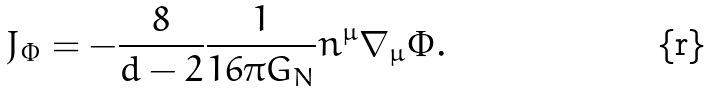<formula> <loc_0><loc_0><loc_500><loc_500>J _ { \Phi } = - \frac { 8 } { d - 2 } \frac { 1 } { 1 6 \pi G _ { N } } n ^ { \mu } \nabla _ { \mu } \Phi .</formula> 